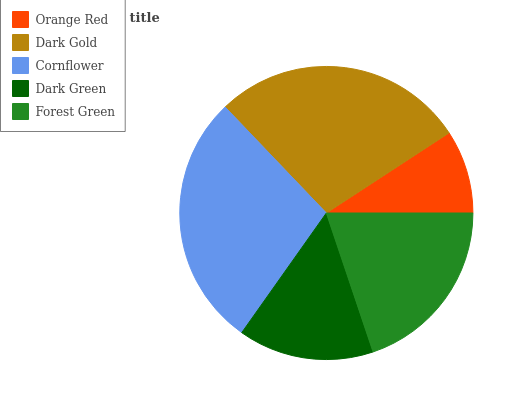Is Orange Red the minimum?
Answer yes or no. Yes. Is Cornflower the maximum?
Answer yes or no. Yes. Is Dark Gold the minimum?
Answer yes or no. No. Is Dark Gold the maximum?
Answer yes or no. No. Is Dark Gold greater than Orange Red?
Answer yes or no. Yes. Is Orange Red less than Dark Gold?
Answer yes or no. Yes. Is Orange Red greater than Dark Gold?
Answer yes or no. No. Is Dark Gold less than Orange Red?
Answer yes or no. No. Is Forest Green the high median?
Answer yes or no. Yes. Is Forest Green the low median?
Answer yes or no. Yes. Is Dark Green the high median?
Answer yes or no. No. Is Orange Red the low median?
Answer yes or no. No. 